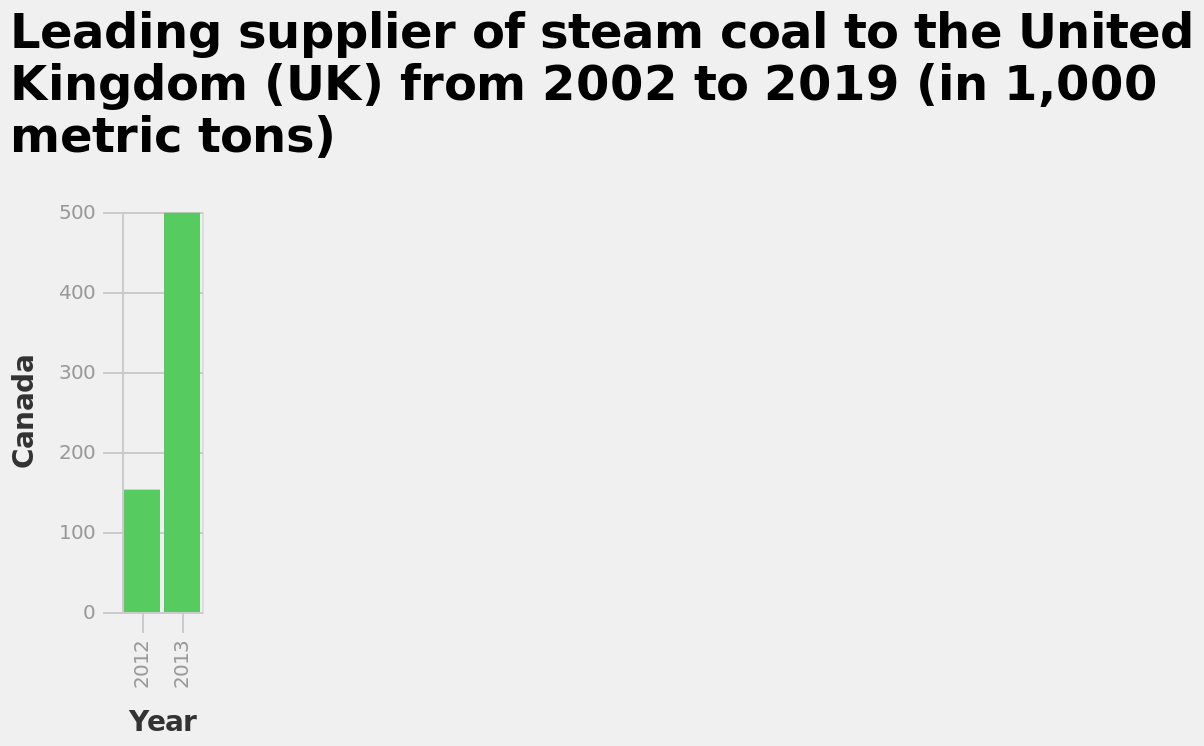<image>
Describe the following image in detail Leading supplier of steam coal to the United Kingdom (UK) from 2002 to 2019 (in 1,000 metric tons) is a bar chart. The x-axis plots Year while the y-axis plots Canada. Offer a thorough analysis of the image. There has been a dramatic increase in the amount of steam coal supplied by Canada. Can you provide some information about the change in the supply of steam coal from Canada? The supply of steam coal from Canada has experienced a significant increase. 